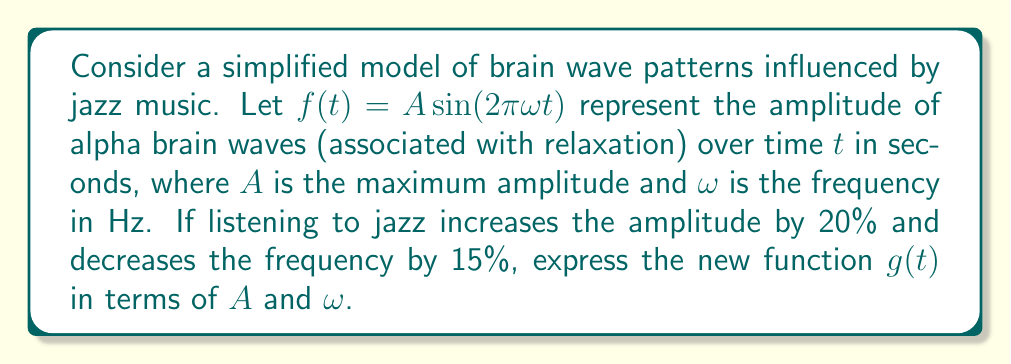Could you help me with this problem? To solve this problem, we'll follow these steps:

1) The original function is given as:
   $f(t) = A \sin(2\pi\omega t)$

2) Listening to jazz increases the amplitude by 20%:
   New amplitude = $A + 20\% \text{ of } A = A + 0.2A = 1.2A$

3) Jazz decreases the frequency by 15%:
   New frequency = $\omega - 15\% \text{ of } \omega = \omega - 0.15\omega = 0.85\omega$

4) Substituting these new values into the original function:
   $g(t) = 1.2A \sin(2\pi(0.85\omega)t)$

5) Simplifying:
   $g(t) = 1.2A \sin(1.7\pi\omega t)$

This new function $g(t)$ represents the modified brain wave pattern when listening to jazz music.
Answer: $g(t) = 1.2A \sin(1.7\pi\omega t)$ 